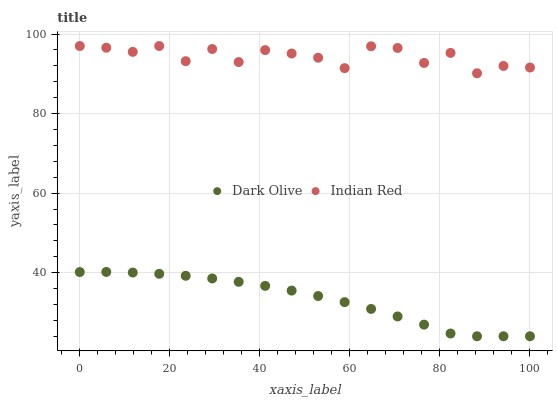Does Dark Olive have the minimum area under the curve?
Answer yes or no. Yes. Does Indian Red have the maximum area under the curve?
Answer yes or no. Yes. Does Indian Red have the minimum area under the curve?
Answer yes or no. No. Is Dark Olive the smoothest?
Answer yes or no. Yes. Is Indian Red the roughest?
Answer yes or no. Yes. Is Indian Red the smoothest?
Answer yes or no. No. Does Dark Olive have the lowest value?
Answer yes or no. Yes. Does Indian Red have the lowest value?
Answer yes or no. No. Does Indian Red have the highest value?
Answer yes or no. Yes. Is Dark Olive less than Indian Red?
Answer yes or no. Yes. Is Indian Red greater than Dark Olive?
Answer yes or no. Yes. Does Dark Olive intersect Indian Red?
Answer yes or no. No. 